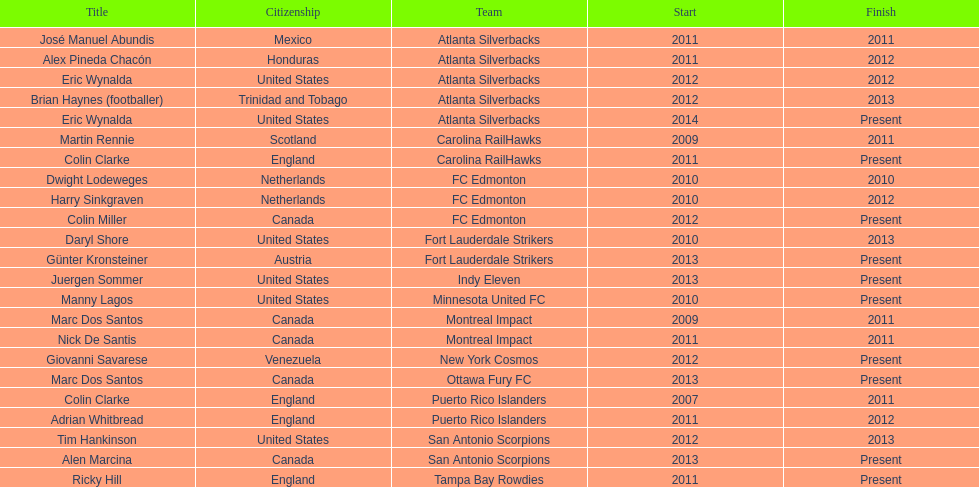How many coaches have coached from america? 6. 